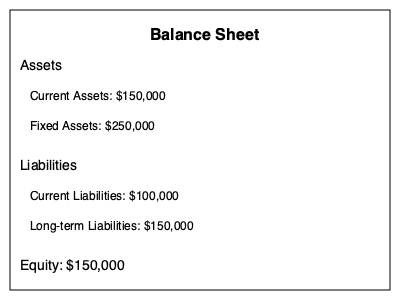Based on the balance sheet diagram, what is the total value of assets, and how does it compare to the combined value of liabilities and equity? To answer this question, we need to follow these steps:

1. Calculate the total value of assets:
   Current Assets: $150,000
   Fixed Assets: $250,000
   Total Assets = $150,000 + $250,000 = $400,000

2. Calculate the total value of liabilities:
   Current Liabilities: $100,000
   Long-term Liabilities: $150,000
   Total Liabilities = $100,000 + $150,000 = $250,000

3. Identify the value of equity:
   Equity: $150,000

4. Calculate the combined value of liabilities and equity:
   Combined value = Total Liabilities + Equity
   Combined value = $250,000 + $150,000 = $400,000

5. Compare the total assets to the combined value of liabilities and equity:
   Total Assets = $400,000
   Combined Liabilities and Equity = $400,000

We can see that the total value of assets ($400,000) is equal to the combined value of liabilities and equity ($400,000). This demonstrates the fundamental accounting equation: Assets = Liabilities + Equity.
Answer: Total assets: $400,000; equal to liabilities plus equity. 